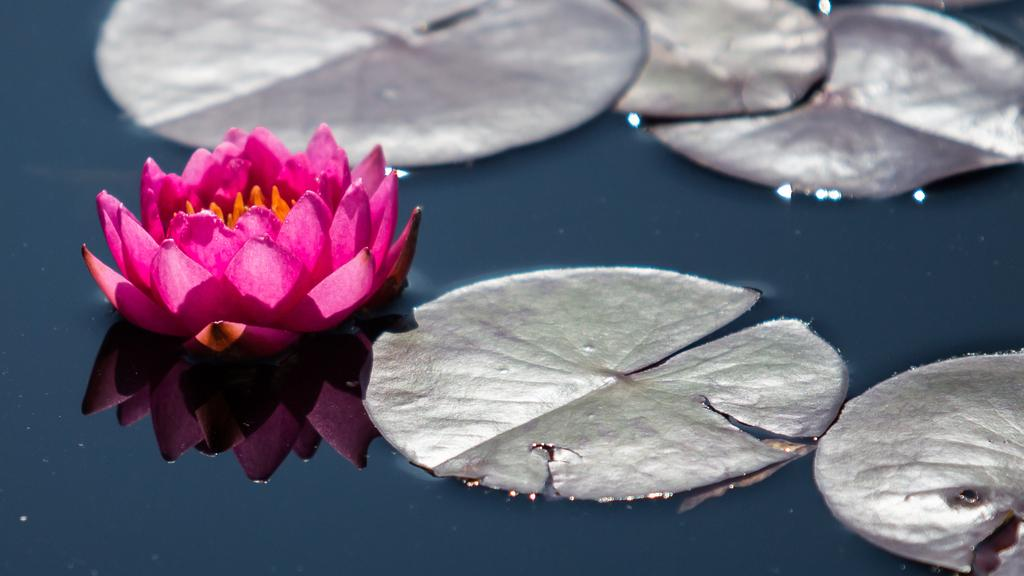What is the main subject of the image? There is a flower in the image. Are there any other plant elements visible in the image? Yes, there are leaves in the image. Where are the flower and leaves located? The flower and leaves are on the water. What type of alarm can be heard going off in the image? There is no alarm present in the image, as it is a still image of a flower and leaves on water. 